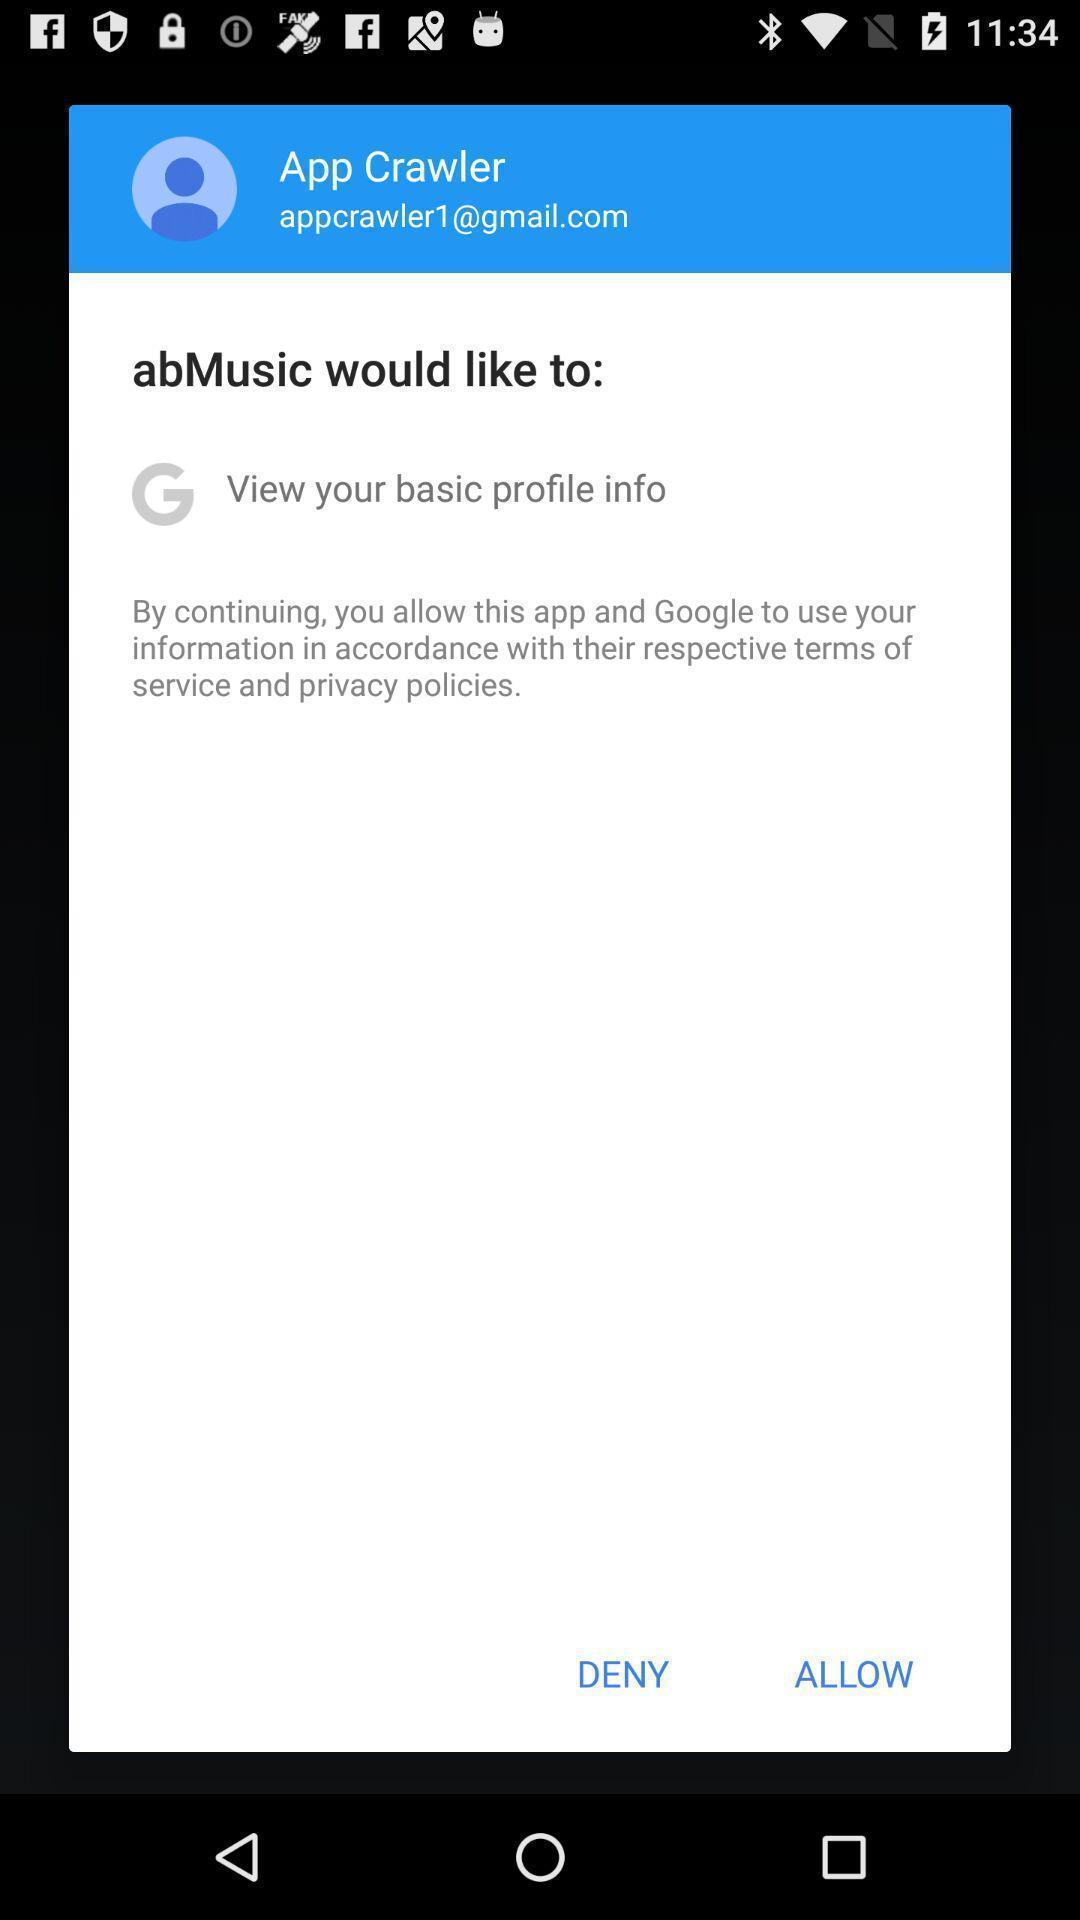Provide a textual representation of this image. Popup page for allowing terms and conditions. 